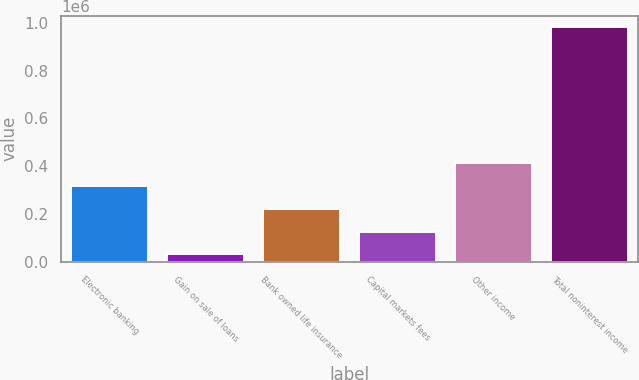Convert chart to OTSL. <chart><loc_0><loc_0><loc_500><loc_500><bar_chart><fcel>Electronic banking<fcel>Gain on sale of loans<fcel>Bank owned life insurance<fcel>Capital markets fees<fcel>Other income<fcel>Total noninterest income<nl><fcel>316548<fcel>31944<fcel>221680<fcel>126812<fcel>411416<fcel>980623<nl></chart> 